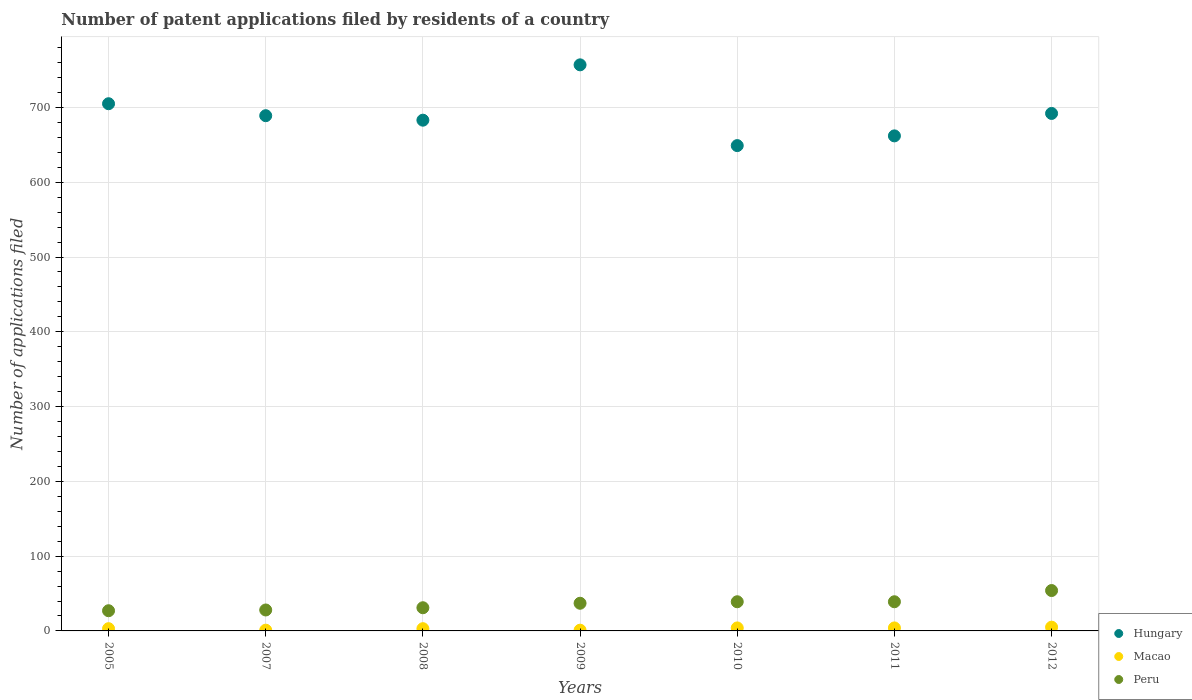What is the number of applications filed in Hungary in 2010?
Keep it short and to the point. 649. Across all years, what is the minimum number of applications filed in Hungary?
Ensure brevity in your answer.  649. What is the total number of applications filed in Hungary in the graph?
Give a very brief answer. 4837. What is the difference between the number of applications filed in Peru in 2011 and the number of applications filed in Hungary in 2008?
Your answer should be very brief. -644. What is the average number of applications filed in Peru per year?
Provide a short and direct response. 36.43. In the year 2007, what is the difference between the number of applications filed in Peru and number of applications filed in Macao?
Provide a short and direct response. 27. What is the ratio of the number of applications filed in Peru in 2010 to that in 2012?
Offer a very short reply. 0.72. Is the number of applications filed in Macao in 2007 less than that in 2012?
Give a very brief answer. Yes. Is it the case that in every year, the sum of the number of applications filed in Peru and number of applications filed in Hungary  is greater than the number of applications filed in Macao?
Your answer should be compact. Yes. Is the number of applications filed in Peru strictly less than the number of applications filed in Hungary over the years?
Ensure brevity in your answer.  Yes. How many dotlines are there?
Give a very brief answer. 3. Are the values on the major ticks of Y-axis written in scientific E-notation?
Ensure brevity in your answer.  No. Does the graph contain grids?
Offer a terse response. Yes. How are the legend labels stacked?
Give a very brief answer. Vertical. What is the title of the graph?
Make the answer very short. Number of patent applications filed by residents of a country. Does "Burkina Faso" appear as one of the legend labels in the graph?
Offer a terse response. No. What is the label or title of the Y-axis?
Keep it short and to the point. Number of applications filed. What is the Number of applications filed in Hungary in 2005?
Offer a very short reply. 705. What is the Number of applications filed of Peru in 2005?
Your response must be concise. 27. What is the Number of applications filed of Hungary in 2007?
Give a very brief answer. 689. What is the Number of applications filed of Macao in 2007?
Your response must be concise. 1. What is the Number of applications filed of Hungary in 2008?
Offer a terse response. 683. What is the Number of applications filed of Hungary in 2009?
Offer a very short reply. 757. What is the Number of applications filed of Hungary in 2010?
Give a very brief answer. 649. What is the Number of applications filed of Macao in 2010?
Your response must be concise. 4. What is the Number of applications filed in Peru in 2010?
Make the answer very short. 39. What is the Number of applications filed of Hungary in 2011?
Give a very brief answer. 662. What is the Number of applications filed in Macao in 2011?
Give a very brief answer. 4. What is the Number of applications filed of Peru in 2011?
Offer a very short reply. 39. What is the Number of applications filed of Hungary in 2012?
Your answer should be compact. 692. What is the Number of applications filed of Macao in 2012?
Your answer should be compact. 5. Across all years, what is the maximum Number of applications filed of Hungary?
Offer a very short reply. 757. Across all years, what is the maximum Number of applications filed in Macao?
Your answer should be compact. 5. Across all years, what is the minimum Number of applications filed in Hungary?
Make the answer very short. 649. What is the total Number of applications filed of Hungary in the graph?
Provide a short and direct response. 4837. What is the total Number of applications filed of Peru in the graph?
Your answer should be compact. 255. What is the difference between the Number of applications filed in Hungary in 2005 and that in 2007?
Ensure brevity in your answer.  16. What is the difference between the Number of applications filed of Peru in 2005 and that in 2007?
Your answer should be compact. -1. What is the difference between the Number of applications filed in Hungary in 2005 and that in 2008?
Your answer should be compact. 22. What is the difference between the Number of applications filed of Macao in 2005 and that in 2008?
Make the answer very short. 0. What is the difference between the Number of applications filed of Hungary in 2005 and that in 2009?
Offer a terse response. -52. What is the difference between the Number of applications filed in Macao in 2005 and that in 2009?
Give a very brief answer. 2. What is the difference between the Number of applications filed in Peru in 2005 and that in 2009?
Keep it short and to the point. -10. What is the difference between the Number of applications filed in Peru in 2005 and that in 2010?
Keep it short and to the point. -12. What is the difference between the Number of applications filed of Macao in 2005 and that in 2011?
Your answer should be very brief. -1. What is the difference between the Number of applications filed of Peru in 2005 and that in 2011?
Your answer should be compact. -12. What is the difference between the Number of applications filed of Hungary in 2005 and that in 2012?
Your response must be concise. 13. What is the difference between the Number of applications filed in Macao in 2005 and that in 2012?
Offer a terse response. -2. What is the difference between the Number of applications filed in Peru in 2005 and that in 2012?
Offer a very short reply. -27. What is the difference between the Number of applications filed in Hungary in 2007 and that in 2008?
Your response must be concise. 6. What is the difference between the Number of applications filed in Hungary in 2007 and that in 2009?
Offer a very short reply. -68. What is the difference between the Number of applications filed in Macao in 2007 and that in 2009?
Keep it short and to the point. 0. What is the difference between the Number of applications filed of Peru in 2007 and that in 2009?
Your response must be concise. -9. What is the difference between the Number of applications filed of Hungary in 2007 and that in 2010?
Your answer should be compact. 40. What is the difference between the Number of applications filed of Macao in 2007 and that in 2010?
Keep it short and to the point. -3. What is the difference between the Number of applications filed of Hungary in 2007 and that in 2011?
Your answer should be very brief. 27. What is the difference between the Number of applications filed of Macao in 2007 and that in 2011?
Ensure brevity in your answer.  -3. What is the difference between the Number of applications filed in Peru in 2007 and that in 2012?
Provide a succinct answer. -26. What is the difference between the Number of applications filed in Hungary in 2008 and that in 2009?
Provide a succinct answer. -74. What is the difference between the Number of applications filed of Peru in 2008 and that in 2009?
Your answer should be compact. -6. What is the difference between the Number of applications filed in Macao in 2008 and that in 2010?
Your answer should be compact. -1. What is the difference between the Number of applications filed in Hungary in 2008 and that in 2011?
Ensure brevity in your answer.  21. What is the difference between the Number of applications filed of Macao in 2008 and that in 2011?
Offer a very short reply. -1. What is the difference between the Number of applications filed in Peru in 2008 and that in 2011?
Offer a terse response. -8. What is the difference between the Number of applications filed of Hungary in 2008 and that in 2012?
Your response must be concise. -9. What is the difference between the Number of applications filed in Macao in 2008 and that in 2012?
Provide a succinct answer. -2. What is the difference between the Number of applications filed of Peru in 2008 and that in 2012?
Your answer should be compact. -23. What is the difference between the Number of applications filed in Hungary in 2009 and that in 2010?
Provide a succinct answer. 108. What is the difference between the Number of applications filed in Macao in 2009 and that in 2010?
Offer a terse response. -3. What is the difference between the Number of applications filed in Peru in 2009 and that in 2010?
Ensure brevity in your answer.  -2. What is the difference between the Number of applications filed in Hungary in 2009 and that in 2011?
Keep it short and to the point. 95. What is the difference between the Number of applications filed of Macao in 2009 and that in 2011?
Provide a succinct answer. -3. What is the difference between the Number of applications filed in Hungary in 2010 and that in 2011?
Keep it short and to the point. -13. What is the difference between the Number of applications filed of Macao in 2010 and that in 2011?
Offer a very short reply. 0. What is the difference between the Number of applications filed in Peru in 2010 and that in 2011?
Ensure brevity in your answer.  0. What is the difference between the Number of applications filed in Hungary in 2010 and that in 2012?
Provide a short and direct response. -43. What is the difference between the Number of applications filed of Peru in 2010 and that in 2012?
Your answer should be very brief. -15. What is the difference between the Number of applications filed of Macao in 2011 and that in 2012?
Make the answer very short. -1. What is the difference between the Number of applications filed in Peru in 2011 and that in 2012?
Your response must be concise. -15. What is the difference between the Number of applications filed in Hungary in 2005 and the Number of applications filed in Macao in 2007?
Provide a succinct answer. 704. What is the difference between the Number of applications filed in Hungary in 2005 and the Number of applications filed in Peru in 2007?
Provide a succinct answer. 677. What is the difference between the Number of applications filed of Hungary in 2005 and the Number of applications filed of Macao in 2008?
Give a very brief answer. 702. What is the difference between the Number of applications filed of Hungary in 2005 and the Number of applications filed of Peru in 2008?
Provide a short and direct response. 674. What is the difference between the Number of applications filed in Hungary in 2005 and the Number of applications filed in Macao in 2009?
Your response must be concise. 704. What is the difference between the Number of applications filed of Hungary in 2005 and the Number of applications filed of Peru in 2009?
Ensure brevity in your answer.  668. What is the difference between the Number of applications filed in Macao in 2005 and the Number of applications filed in Peru in 2009?
Make the answer very short. -34. What is the difference between the Number of applications filed of Hungary in 2005 and the Number of applications filed of Macao in 2010?
Ensure brevity in your answer.  701. What is the difference between the Number of applications filed in Hungary in 2005 and the Number of applications filed in Peru in 2010?
Provide a short and direct response. 666. What is the difference between the Number of applications filed in Macao in 2005 and the Number of applications filed in Peru in 2010?
Your response must be concise. -36. What is the difference between the Number of applications filed in Hungary in 2005 and the Number of applications filed in Macao in 2011?
Keep it short and to the point. 701. What is the difference between the Number of applications filed of Hungary in 2005 and the Number of applications filed of Peru in 2011?
Make the answer very short. 666. What is the difference between the Number of applications filed in Macao in 2005 and the Number of applications filed in Peru in 2011?
Make the answer very short. -36. What is the difference between the Number of applications filed in Hungary in 2005 and the Number of applications filed in Macao in 2012?
Offer a terse response. 700. What is the difference between the Number of applications filed in Hungary in 2005 and the Number of applications filed in Peru in 2012?
Your answer should be very brief. 651. What is the difference between the Number of applications filed in Macao in 2005 and the Number of applications filed in Peru in 2012?
Make the answer very short. -51. What is the difference between the Number of applications filed of Hungary in 2007 and the Number of applications filed of Macao in 2008?
Your answer should be compact. 686. What is the difference between the Number of applications filed in Hungary in 2007 and the Number of applications filed in Peru in 2008?
Make the answer very short. 658. What is the difference between the Number of applications filed in Macao in 2007 and the Number of applications filed in Peru in 2008?
Keep it short and to the point. -30. What is the difference between the Number of applications filed in Hungary in 2007 and the Number of applications filed in Macao in 2009?
Ensure brevity in your answer.  688. What is the difference between the Number of applications filed of Hungary in 2007 and the Number of applications filed of Peru in 2009?
Provide a short and direct response. 652. What is the difference between the Number of applications filed of Macao in 2007 and the Number of applications filed of Peru in 2009?
Offer a very short reply. -36. What is the difference between the Number of applications filed of Hungary in 2007 and the Number of applications filed of Macao in 2010?
Offer a very short reply. 685. What is the difference between the Number of applications filed in Hungary in 2007 and the Number of applications filed in Peru in 2010?
Make the answer very short. 650. What is the difference between the Number of applications filed of Macao in 2007 and the Number of applications filed of Peru in 2010?
Your answer should be compact. -38. What is the difference between the Number of applications filed in Hungary in 2007 and the Number of applications filed in Macao in 2011?
Your answer should be compact. 685. What is the difference between the Number of applications filed of Hungary in 2007 and the Number of applications filed of Peru in 2011?
Give a very brief answer. 650. What is the difference between the Number of applications filed of Macao in 2007 and the Number of applications filed of Peru in 2011?
Offer a terse response. -38. What is the difference between the Number of applications filed of Hungary in 2007 and the Number of applications filed of Macao in 2012?
Your answer should be very brief. 684. What is the difference between the Number of applications filed of Hungary in 2007 and the Number of applications filed of Peru in 2012?
Offer a terse response. 635. What is the difference between the Number of applications filed in Macao in 2007 and the Number of applications filed in Peru in 2012?
Offer a terse response. -53. What is the difference between the Number of applications filed of Hungary in 2008 and the Number of applications filed of Macao in 2009?
Offer a very short reply. 682. What is the difference between the Number of applications filed of Hungary in 2008 and the Number of applications filed of Peru in 2009?
Offer a terse response. 646. What is the difference between the Number of applications filed in Macao in 2008 and the Number of applications filed in Peru in 2009?
Make the answer very short. -34. What is the difference between the Number of applications filed in Hungary in 2008 and the Number of applications filed in Macao in 2010?
Make the answer very short. 679. What is the difference between the Number of applications filed in Hungary in 2008 and the Number of applications filed in Peru in 2010?
Offer a terse response. 644. What is the difference between the Number of applications filed of Macao in 2008 and the Number of applications filed of Peru in 2010?
Make the answer very short. -36. What is the difference between the Number of applications filed in Hungary in 2008 and the Number of applications filed in Macao in 2011?
Provide a short and direct response. 679. What is the difference between the Number of applications filed of Hungary in 2008 and the Number of applications filed of Peru in 2011?
Ensure brevity in your answer.  644. What is the difference between the Number of applications filed in Macao in 2008 and the Number of applications filed in Peru in 2011?
Make the answer very short. -36. What is the difference between the Number of applications filed of Hungary in 2008 and the Number of applications filed of Macao in 2012?
Provide a succinct answer. 678. What is the difference between the Number of applications filed of Hungary in 2008 and the Number of applications filed of Peru in 2012?
Keep it short and to the point. 629. What is the difference between the Number of applications filed in Macao in 2008 and the Number of applications filed in Peru in 2012?
Keep it short and to the point. -51. What is the difference between the Number of applications filed in Hungary in 2009 and the Number of applications filed in Macao in 2010?
Provide a short and direct response. 753. What is the difference between the Number of applications filed in Hungary in 2009 and the Number of applications filed in Peru in 2010?
Keep it short and to the point. 718. What is the difference between the Number of applications filed of Macao in 2009 and the Number of applications filed of Peru in 2010?
Give a very brief answer. -38. What is the difference between the Number of applications filed in Hungary in 2009 and the Number of applications filed in Macao in 2011?
Keep it short and to the point. 753. What is the difference between the Number of applications filed of Hungary in 2009 and the Number of applications filed of Peru in 2011?
Your response must be concise. 718. What is the difference between the Number of applications filed of Macao in 2009 and the Number of applications filed of Peru in 2011?
Your answer should be compact. -38. What is the difference between the Number of applications filed of Hungary in 2009 and the Number of applications filed of Macao in 2012?
Make the answer very short. 752. What is the difference between the Number of applications filed in Hungary in 2009 and the Number of applications filed in Peru in 2012?
Offer a terse response. 703. What is the difference between the Number of applications filed of Macao in 2009 and the Number of applications filed of Peru in 2012?
Offer a very short reply. -53. What is the difference between the Number of applications filed in Hungary in 2010 and the Number of applications filed in Macao in 2011?
Give a very brief answer. 645. What is the difference between the Number of applications filed of Hungary in 2010 and the Number of applications filed of Peru in 2011?
Offer a terse response. 610. What is the difference between the Number of applications filed in Macao in 2010 and the Number of applications filed in Peru in 2011?
Your answer should be very brief. -35. What is the difference between the Number of applications filed in Hungary in 2010 and the Number of applications filed in Macao in 2012?
Make the answer very short. 644. What is the difference between the Number of applications filed in Hungary in 2010 and the Number of applications filed in Peru in 2012?
Offer a very short reply. 595. What is the difference between the Number of applications filed of Hungary in 2011 and the Number of applications filed of Macao in 2012?
Offer a terse response. 657. What is the difference between the Number of applications filed in Hungary in 2011 and the Number of applications filed in Peru in 2012?
Offer a very short reply. 608. What is the difference between the Number of applications filed in Macao in 2011 and the Number of applications filed in Peru in 2012?
Your response must be concise. -50. What is the average Number of applications filed in Hungary per year?
Your answer should be very brief. 691. What is the average Number of applications filed of Macao per year?
Give a very brief answer. 3. What is the average Number of applications filed in Peru per year?
Provide a short and direct response. 36.43. In the year 2005, what is the difference between the Number of applications filed in Hungary and Number of applications filed in Macao?
Offer a terse response. 702. In the year 2005, what is the difference between the Number of applications filed of Hungary and Number of applications filed of Peru?
Your answer should be very brief. 678. In the year 2007, what is the difference between the Number of applications filed in Hungary and Number of applications filed in Macao?
Offer a terse response. 688. In the year 2007, what is the difference between the Number of applications filed of Hungary and Number of applications filed of Peru?
Your answer should be compact. 661. In the year 2008, what is the difference between the Number of applications filed in Hungary and Number of applications filed in Macao?
Your response must be concise. 680. In the year 2008, what is the difference between the Number of applications filed of Hungary and Number of applications filed of Peru?
Ensure brevity in your answer.  652. In the year 2008, what is the difference between the Number of applications filed in Macao and Number of applications filed in Peru?
Offer a terse response. -28. In the year 2009, what is the difference between the Number of applications filed in Hungary and Number of applications filed in Macao?
Your response must be concise. 756. In the year 2009, what is the difference between the Number of applications filed of Hungary and Number of applications filed of Peru?
Provide a succinct answer. 720. In the year 2009, what is the difference between the Number of applications filed of Macao and Number of applications filed of Peru?
Your response must be concise. -36. In the year 2010, what is the difference between the Number of applications filed of Hungary and Number of applications filed of Macao?
Your answer should be compact. 645. In the year 2010, what is the difference between the Number of applications filed in Hungary and Number of applications filed in Peru?
Your answer should be compact. 610. In the year 2010, what is the difference between the Number of applications filed of Macao and Number of applications filed of Peru?
Offer a very short reply. -35. In the year 2011, what is the difference between the Number of applications filed of Hungary and Number of applications filed of Macao?
Your answer should be compact. 658. In the year 2011, what is the difference between the Number of applications filed of Hungary and Number of applications filed of Peru?
Ensure brevity in your answer.  623. In the year 2011, what is the difference between the Number of applications filed in Macao and Number of applications filed in Peru?
Provide a short and direct response. -35. In the year 2012, what is the difference between the Number of applications filed in Hungary and Number of applications filed in Macao?
Keep it short and to the point. 687. In the year 2012, what is the difference between the Number of applications filed in Hungary and Number of applications filed in Peru?
Your answer should be compact. 638. In the year 2012, what is the difference between the Number of applications filed in Macao and Number of applications filed in Peru?
Provide a succinct answer. -49. What is the ratio of the Number of applications filed in Hungary in 2005 to that in 2007?
Offer a terse response. 1.02. What is the ratio of the Number of applications filed of Peru in 2005 to that in 2007?
Your response must be concise. 0.96. What is the ratio of the Number of applications filed in Hungary in 2005 to that in 2008?
Provide a succinct answer. 1.03. What is the ratio of the Number of applications filed of Macao in 2005 to that in 2008?
Provide a short and direct response. 1. What is the ratio of the Number of applications filed of Peru in 2005 to that in 2008?
Provide a succinct answer. 0.87. What is the ratio of the Number of applications filed of Hungary in 2005 to that in 2009?
Give a very brief answer. 0.93. What is the ratio of the Number of applications filed of Macao in 2005 to that in 2009?
Offer a terse response. 3. What is the ratio of the Number of applications filed of Peru in 2005 to that in 2009?
Offer a very short reply. 0.73. What is the ratio of the Number of applications filed of Hungary in 2005 to that in 2010?
Your answer should be compact. 1.09. What is the ratio of the Number of applications filed in Macao in 2005 to that in 2010?
Your answer should be compact. 0.75. What is the ratio of the Number of applications filed of Peru in 2005 to that in 2010?
Offer a terse response. 0.69. What is the ratio of the Number of applications filed in Hungary in 2005 to that in 2011?
Offer a very short reply. 1.06. What is the ratio of the Number of applications filed in Peru in 2005 to that in 2011?
Your response must be concise. 0.69. What is the ratio of the Number of applications filed in Hungary in 2005 to that in 2012?
Your answer should be very brief. 1.02. What is the ratio of the Number of applications filed of Macao in 2005 to that in 2012?
Provide a succinct answer. 0.6. What is the ratio of the Number of applications filed in Peru in 2005 to that in 2012?
Your answer should be very brief. 0.5. What is the ratio of the Number of applications filed of Hungary in 2007 to that in 2008?
Your response must be concise. 1.01. What is the ratio of the Number of applications filed of Peru in 2007 to that in 2008?
Offer a terse response. 0.9. What is the ratio of the Number of applications filed of Hungary in 2007 to that in 2009?
Your answer should be compact. 0.91. What is the ratio of the Number of applications filed in Macao in 2007 to that in 2009?
Make the answer very short. 1. What is the ratio of the Number of applications filed of Peru in 2007 to that in 2009?
Make the answer very short. 0.76. What is the ratio of the Number of applications filed of Hungary in 2007 to that in 2010?
Give a very brief answer. 1.06. What is the ratio of the Number of applications filed of Peru in 2007 to that in 2010?
Make the answer very short. 0.72. What is the ratio of the Number of applications filed in Hungary in 2007 to that in 2011?
Offer a terse response. 1.04. What is the ratio of the Number of applications filed of Peru in 2007 to that in 2011?
Ensure brevity in your answer.  0.72. What is the ratio of the Number of applications filed in Macao in 2007 to that in 2012?
Offer a very short reply. 0.2. What is the ratio of the Number of applications filed of Peru in 2007 to that in 2012?
Provide a succinct answer. 0.52. What is the ratio of the Number of applications filed of Hungary in 2008 to that in 2009?
Your answer should be compact. 0.9. What is the ratio of the Number of applications filed in Macao in 2008 to that in 2009?
Provide a short and direct response. 3. What is the ratio of the Number of applications filed in Peru in 2008 to that in 2009?
Keep it short and to the point. 0.84. What is the ratio of the Number of applications filed of Hungary in 2008 to that in 2010?
Your answer should be very brief. 1.05. What is the ratio of the Number of applications filed of Macao in 2008 to that in 2010?
Keep it short and to the point. 0.75. What is the ratio of the Number of applications filed in Peru in 2008 to that in 2010?
Give a very brief answer. 0.79. What is the ratio of the Number of applications filed of Hungary in 2008 to that in 2011?
Keep it short and to the point. 1.03. What is the ratio of the Number of applications filed of Macao in 2008 to that in 2011?
Provide a succinct answer. 0.75. What is the ratio of the Number of applications filed in Peru in 2008 to that in 2011?
Your response must be concise. 0.79. What is the ratio of the Number of applications filed in Hungary in 2008 to that in 2012?
Provide a succinct answer. 0.99. What is the ratio of the Number of applications filed of Peru in 2008 to that in 2012?
Provide a short and direct response. 0.57. What is the ratio of the Number of applications filed of Hungary in 2009 to that in 2010?
Offer a terse response. 1.17. What is the ratio of the Number of applications filed in Peru in 2009 to that in 2010?
Your response must be concise. 0.95. What is the ratio of the Number of applications filed of Hungary in 2009 to that in 2011?
Offer a very short reply. 1.14. What is the ratio of the Number of applications filed in Macao in 2009 to that in 2011?
Make the answer very short. 0.25. What is the ratio of the Number of applications filed of Peru in 2009 to that in 2011?
Ensure brevity in your answer.  0.95. What is the ratio of the Number of applications filed of Hungary in 2009 to that in 2012?
Provide a succinct answer. 1.09. What is the ratio of the Number of applications filed of Macao in 2009 to that in 2012?
Your answer should be very brief. 0.2. What is the ratio of the Number of applications filed in Peru in 2009 to that in 2012?
Provide a short and direct response. 0.69. What is the ratio of the Number of applications filed of Hungary in 2010 to that in 2011?
Your answer should be compact. 0.98. What is the ratio of the Number of applications filed in Macao in 2010 to that in 2011?
Give a very brief answer. 1. What is the ratio of the Number of applications filed in Peru in 2010 to that in 2011?
Make the answer very short. 1. What is the ratio of the Number of applications filed of Hungary in 2010 to that in 2012?
Ensure brevity in your answer.  0.94. What is the ratio of the Number of applications filed of Peru in 2010 to that in 2012?
Give a very brief answer. 0.72. What is the ratio of the Number of applications filed of Hungary in 2011 to that in 2012?
Offer a terse response. 0.96. What is the ratio of the Number of applications filed of Macao in 2011 to that in 2012?
Provide a short and direct response. 0.8. What is the ratio of the Number of applications filed of Peru in 2011 to that in 2012?
Your answer should be compact. 0.72. What is the difference between the highest and the second highest Number of applications filed in Hungary?
Provide a short and direct response. 52. What is the difference between the highest and the second highest Number of applications filed of Macao?
Ensure brevity in your answer.  1. What is the difference between the highest and the second highest Number of applications filed of Peru?
Give a very brief answer. 15. What is the difference between the highest and the lowest Number of applications filed of Hungary?
Offer a terse response. 108. What is the difference between the highest and the lowest Number of applications filed of Macao?
Offer a very short reply. 4. 